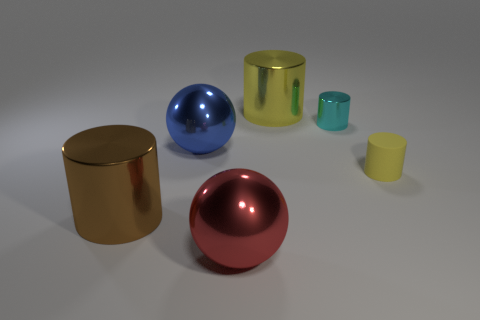Is there any other thing that has the same material as the tiny yellow cylinder?
Offer a terse response. No. What number of small objects are yellow shiny cylinders or blue metal spheres?
Your answer should be compact. 0. What is the size of the red metallic sphere?
Make the answer very short. Large. There is a cyan shiny cylinder; is its size the same as the shiny object that is behind the tiny cyan cylinder?
Make the answer very short. No. How many yellow things are either matte objects or big metal cylinders?
Your answer should be compact. 2. How many cylinders are there?
Give a very brief answer. 4. How big is the shiny cylinder in front of the tiny yellow rubber object?
Offer a terse response. Large. Do the yellow rubber object and the cyan cylinder have the same size?
Your answer should be compact. Yes. What number of objects are big yellow metal cylinders or yellow objects behind the tiny yellow cylinder?
Keep it short and to the point. 1. What is the large red sphere made of?
Offer a terse response. Metal. 